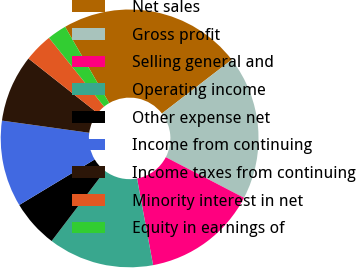Convert chart to OTSL. <chart><loc_0><loc_0><loc_500><loc_500><pie_chart><fcel>Net sales<fcel>Gross profit<fcel>Selling general and<fcel>Operating income<fcel>Other expense net<fcel>Income from continuing<fcel>Income taxes from continuing<fcel>Minority interest in net<fcel>Equity in earnings of<nl><fcel>22.89%<fcel>18.07%<fcel>14.46%<fcel>13.25%<fcel>6.02%<fcel>10.84%<fcel>8.43%<fcel>3.61%<fcel>2.41%<nl></chart> 